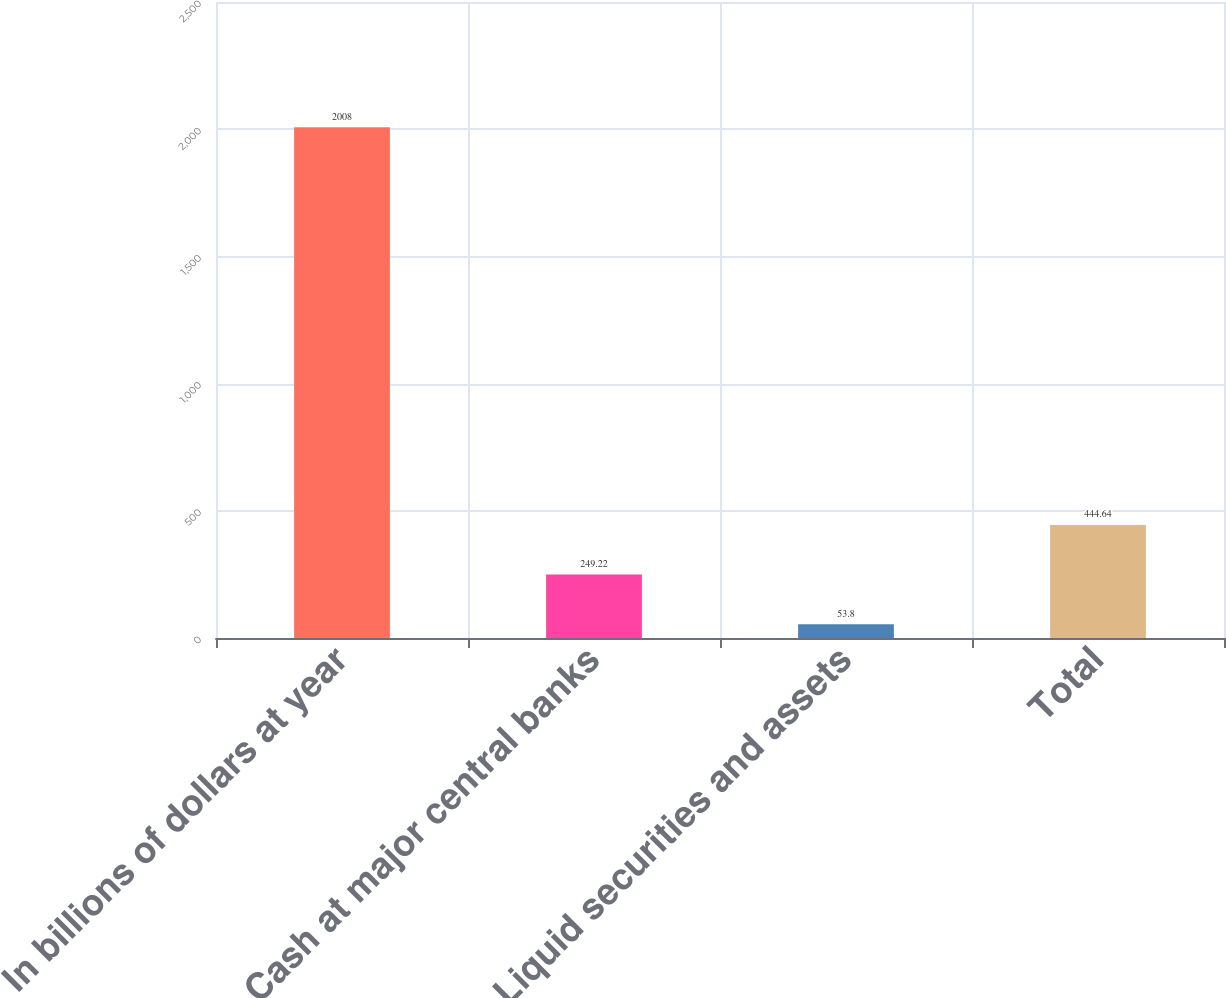Convert chart. <chart><loc_0><loc_0><loc_500><loc_500><bar_chart><fcel>In billions of dollars at year<fcel>Cash at major central banks<fcel>Liquid securities and assets<fcel>Total<nl><fcel>2008<fcel>249.22<fcel>53.8<fcel>444.64<nl></chart> 